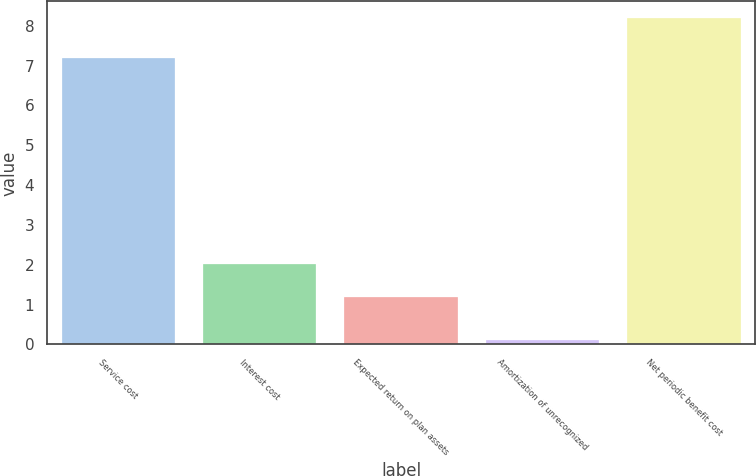Convert chart to OTSL. <chart><loc_0><loc_0><loc_500><loc_500><bar_chart><fcel>Service cost<fcel>Interest cost<fcel>Expected return on plan assets<fcel>Amortization of unrecognized<fcel>Net periodic benefit cost<nl><fcel>7.2<fcel>2.01<fcel>1.2<fcel>0.1<fcel>8.2<nl></chart> 